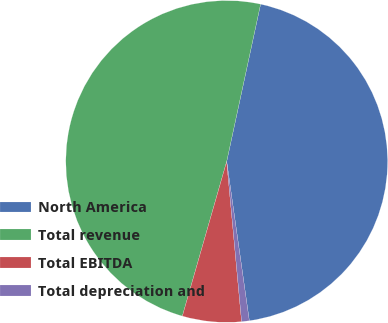Convert chart. <chart><loc_0><loc_0><loc_500><loc_500><pie_chart><fcel>North America<fcel>Total revenue<fcel>Total EBITDA<fcel>Total depreciation and<nl><fcel>44.37%<fcel>48.93%<fcel>5.92%<fcel>0.77%<nl></chart> 